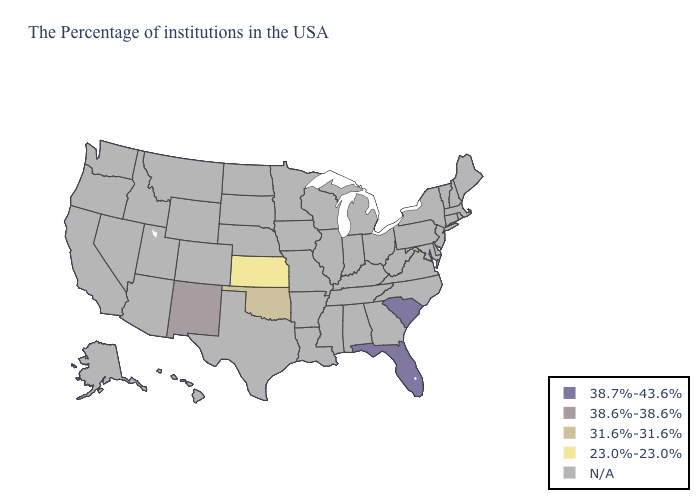Name the states that have a value in the range N/A?
Give a very brief answer. Maine, Massachusetts, Rhode Island, New Hampshire, Vermont, Connecticut, New York, New Jersey, Delaware, Maryland, Pennsylvania, Virginia, North Carolina, West Virginia, Ohio, Georgia, Michigan, Kentucky, Indiana, Alabama, Tennessee, Wisconsin, Illinois, Mississippi, Louisiana, Missouri, Arkansas, Minnesota, Iowa, Nebraska, Texas, South Dakota, North Dakota, Wyoming, Colorado, Utah, Montana, Arizona, Idaho, Nevada, California, Washington, Oregon, Alaska, Hawaii. Does the map have missing data?
Concise answer only. Yes. What is the value of New Hampshire?
Answer briefly. N/A. Does South Carolina have the lowest value in the South?
Quick response, please. No. Name the states that have a value in the range 38.6%-38.6%?
Short answer required. New Mexico. Which states have the highest value in the USA?
Be succinct. South Carolina, Florida. How many symbols are there in the legend?
Answer briefly. 5. How many symbols are there in the legend?
Write a very short answer. 5. What is the lowest value in the West?
Quick response, please. 38.6%-38.6%. What is the value of Alabama?
Quick response, please. N/A. Does the map have missing data?
Concise answer only. Yes. Name the states that have a value in the range 23.0%-23.0%?
Keep it brief. Kansas. What is the lowest value in the South?
Be succinct. 31.6%-31.6%. What is the value of North Carolina?
Write a very short answer. N/A. 